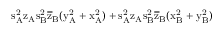<formula> <loc_0><loc_0><loc_500><loc_500>s _ { A } ^ { 2 } \mathrm { z _ { A } \mathrm { s _ { B } ^ { 2 } \mathrm { \overline { z } _ { B } ( \mathrm { y _ { A } ^ { 2 } + \mathrm { x _ { A } ^ { 2 } ) + \mathrm { s _ { A } ^ { 2 } \mathrm { z _ { A } \mathrm { s _ { B } ^ { 2 } \mathrm { \overline { z } _ { B } ( \mathrm { x _ { B } ^ { 2 } + \mathrm { y _ { B } ^ { 2 } ) } } } } } } } } } } }</formula> 